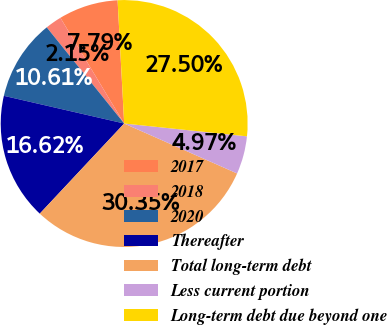Convert chart. <chart><loc_0><loc_0><loc_500><loc_500><pie_chart><fcel>2017<fcel>2018<fcel>2020<fcel>Thereafter<fcel>Total long-term debt<fcel>Less current portion<fcel>Long-term debt due beyond one<nl><fcel>7.79%<fcel>2.15%<fcel>10.61%<fcel>16.62%<fcel>30.35%<fcel>4.97%<fcel>27.5%<nl></chart> 